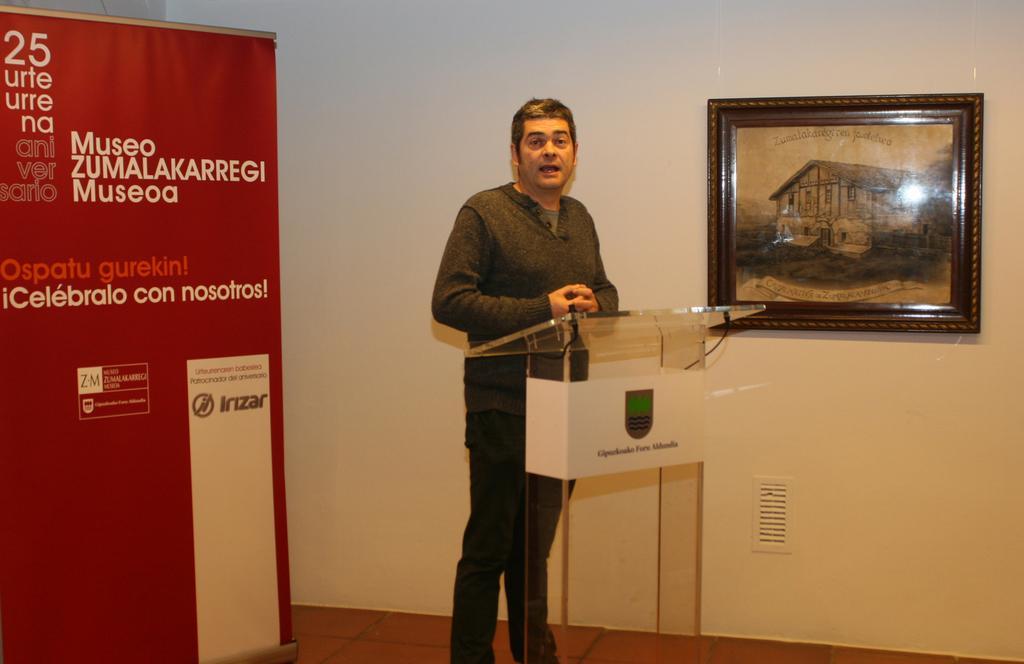Please provide a concise description of this image. In the image we can see there is a person standing near the podium and there is a photo frame on the wall. Behind there is a banner. 